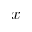<formula> <loc_0><loc_0><loc_500><loc_500>x</formula> 